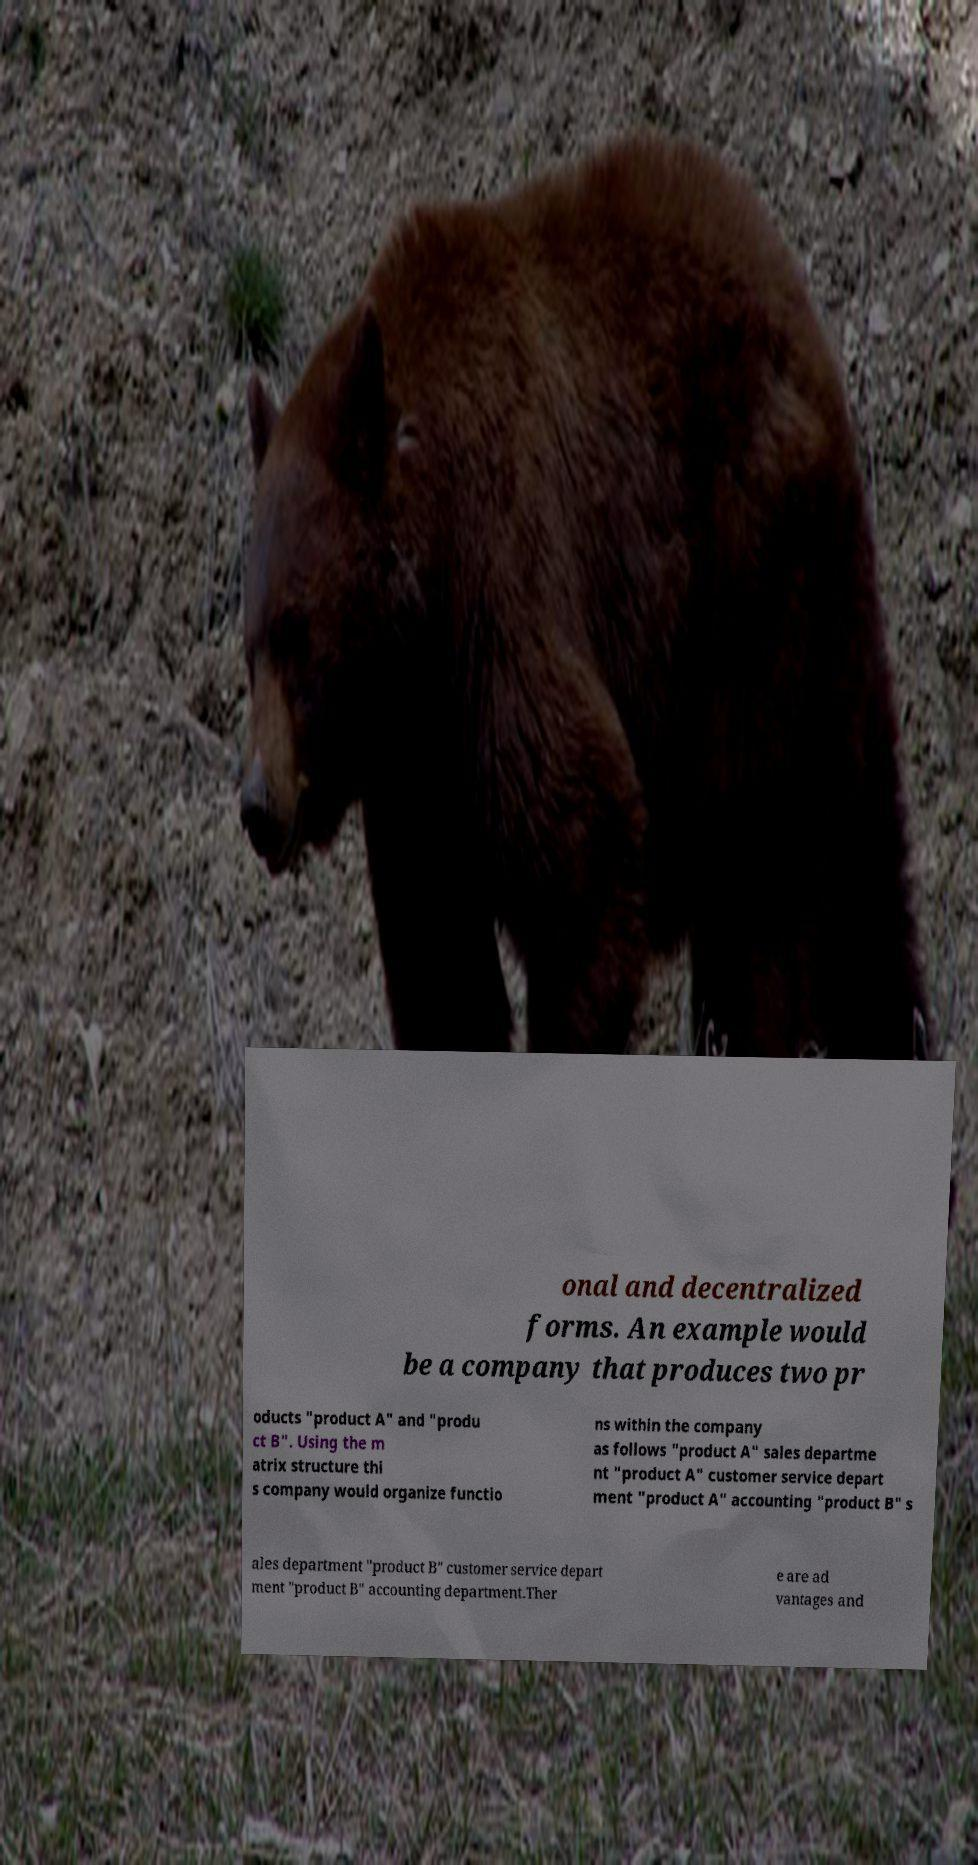Could you assist in decoding the text presented in this image and type it out clearly? onal and decentralized forms. An example would be a company that produces two pr oducts "product A" and "produ ct B". Using the m atrix structure thi s company would organize functio ns within the company as follows "product A" sales departme nt "product A" customer service depart ment "product A" accounting "product B" s ales department "product B" customer service depart ment "product B" accounting department.Ther e are ad vantages and 